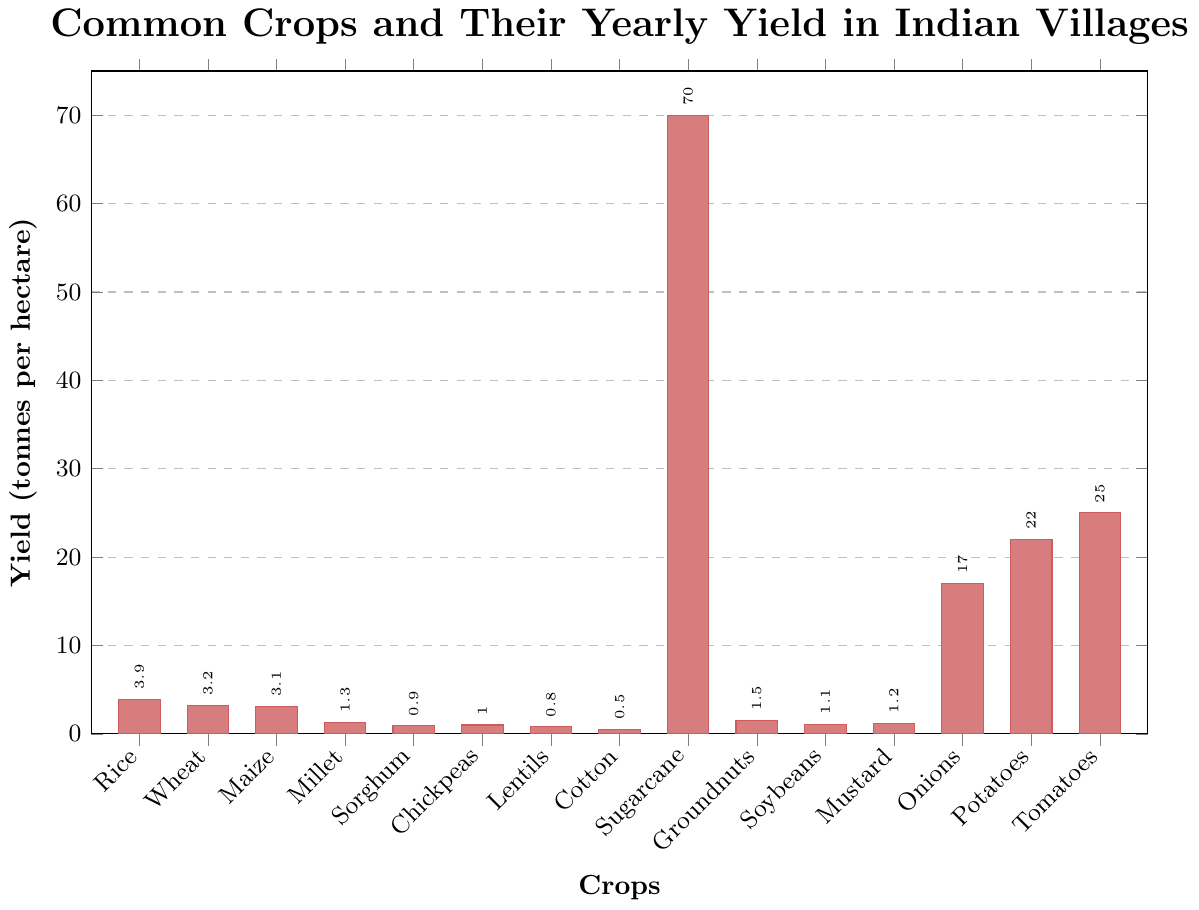Which crop has the highest yield per hectare? The highest bar in the chart represents the crop with the highest yield per hectare. That bar is for Sugarcane.
Answer: Sugarcane What is the combined yield of Rice and Wheat? From the chart, Rice has a yield of 3.9 tonnes per hectare and Wheat has a yield of 3.2 tonnes per hectare. The combined yield is 3.9 + 3.2 = 7.1.
Answer: 7.1 How much more is the yield of Tomatoes compared to Chickpeas? The yield of Tomatoes is 25.0 tonnes per hectare, and the yield of Chickpeas is 1.0 tonnes per hectare. The difference is 25.0 - 1.0 = 24.0.
Answer: 24.0 Is the yield of Potatoes greater than the yield of Onions? The chart shows the yield of Potatoes as 22.0 tonnes per hectare and the yield of Onions as 17.0 tonnes per hectare. Since 22.0 is greater than 17.0, the yield of Potatoes is greater.
Answer: Yes What is the median yield among the crops listed? First, list the yields in ascending order: 0.5, 0.8, 0.9, 1.0, 1.1, 1.2, 1.3, 1.5, 3.1, 3.2, 3.9, 17.0, 22.0, 25.0, 70.0. The middle value (8th in this case) is 1.5.
Answer: 1.5 Which crop has the lowest yield per hectare? The shortest bar in the chart represents the crop with the lowest yield per hectare. That bar is for Cotton.
Answer: Cotton How does the yield of Soybeans compare to the yield of Sorghum? From the chart, Soybeans have a yield of 1.1 tonnes per hectare, and Sorghum has a yield of 0.9 tonnes per hectare. Since 1.1 is greater than 0.9, the yield of Soybeans is higher.
Answer: Higher What is the average yield of the pulses (Chickpeas and Lentils)? The yield of Chickpeas is 1.0 tonnes per hectare and the yield of Lentils is 0.8 tonnes per hectare. The average yield is (1.0 + 0.8) / 2 = 0.9.
Answer: 0.9 Are there any crops with a yield between 10 and 20 tonnes per hectare? The crops that have yields in this range are identified from the bars. Onions have a yield of 17.0 tonnes per hectare.
Answer: Yes, Onions 